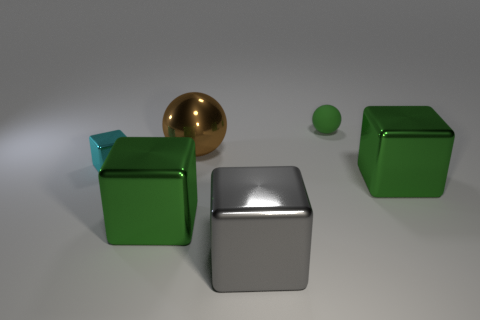What is the material of the green thing that is the same shape as the big brown metallic object?
Ensure brevity in your answer.  Rubber. Is the number of gray objects in front of the large gray thing less than the number of red blocks?
Offer a very short reply. No. What number of cyan cubes are the same size as the green matte object?
Provide a succinct answer. 1. What shape is the green thing that is in front of the large green thing that is behind the large green thing that is left of the brown thing?
Make the answer very short. Cube. The large metallic object that is behind the tiny cube is what color?
Provide a short and direct response. Brown. What number of things are either shiny things that are behind the tiny metallic object or shiny blocks in front of the small rubber sphere?
Offer a terse response. 5. What number of gray metal things have the same shape as the small green rubber object?
Offer a terse response. 0. The block that is the same size as the green ball is what color?
Your response must be concise. Cyan. What is the color of the large shiny thing behind the big metal block behind the large green cube that is to the left of the brown object?
Give a very brief answer. Brown. There is a brown shiny ball; is it the same size as the cyan metal cube that is left of the green ball?
Your answer should be compact. No. 